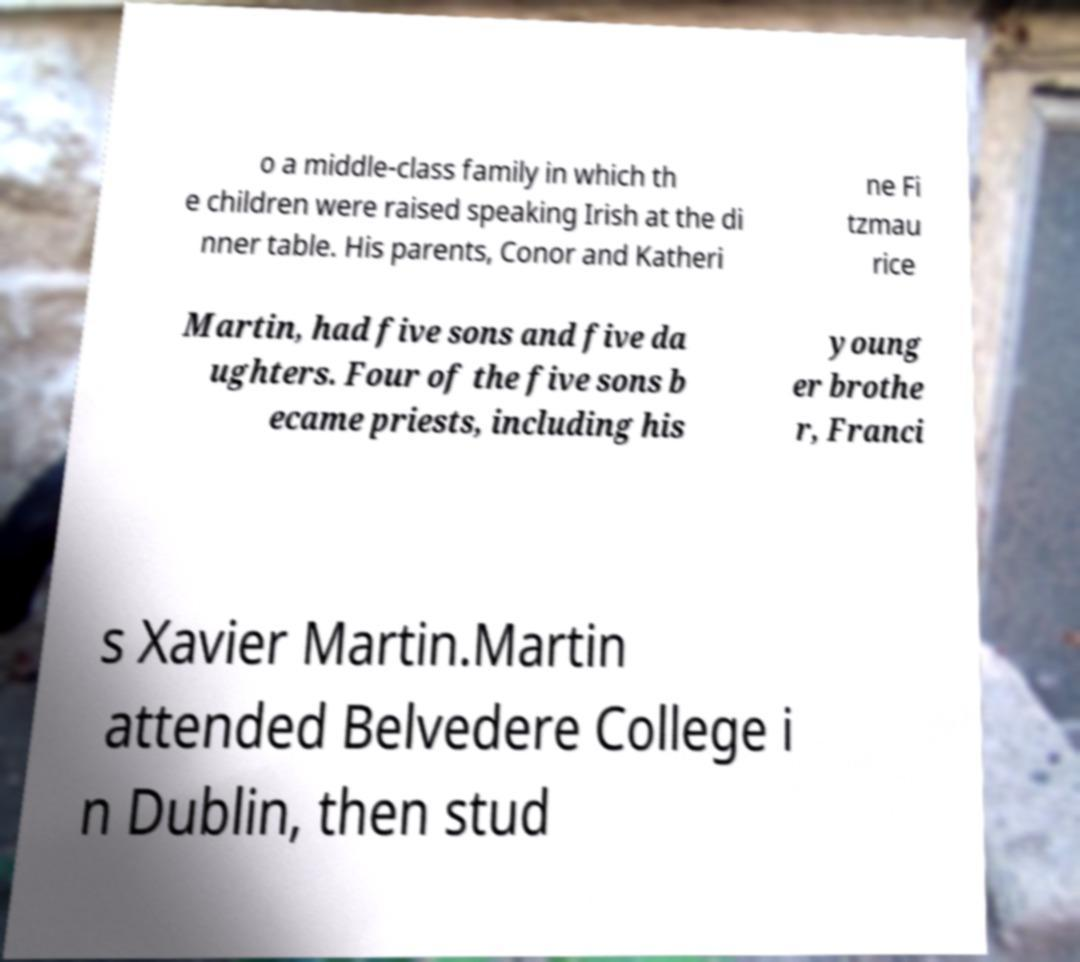Could you assist in decoding the text presented in this image and type it out clearly? o a middle-class family in which th e children were raised speaking Irish at the di nner table. His parents, Conor and Katheri ne Fi tzmau rice Martin, had five sons and five da ughters. Four of the five sons b ecame priests, including his young er brothe r, Franci s Xavier Martin.Martin attended Belvedere College i n Dublin, then stud 